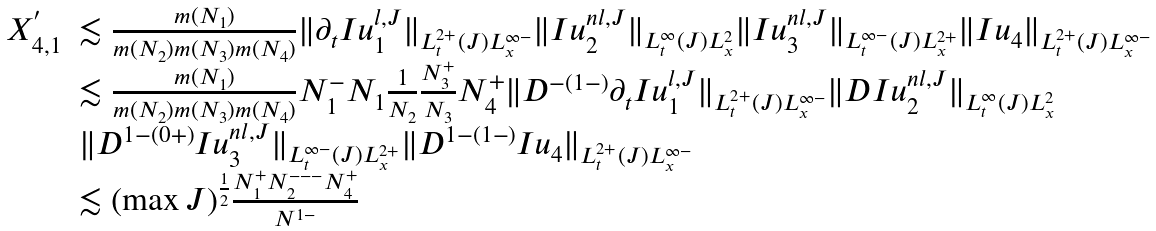Convert formula to latex. <formula><loc_0><loc_0><loc_500><loc_500>\begin{array} { l l } X ^ { ^ { \prime } } _ { 4 , 1 } & \lesssim \frac { m ( N _ { 1 } ) } { m ( N _ { 2 } ) m ( N _ { 3 } ) m ( N _ { 4 } ) } \| \partial _ { t } I u _ { 1 } ^ { l , J } \| _ { L _ { t } ^ { 2 + } ( J ) L _ { x } ^ { \infty - } } \| I u _ { 2 } ^ { n l , J } \| _ { L _ { t } ^ { \infty } ( J ) L _ { x } ^ { 2 } } \| I u _ { 3 } ^ { n l , J } \| _ { L _ { t } ^ { \infty - } ( J ) L _ { x } ^ { 2 + } } \| I u _ { 4 } \| _ { L _ { t } ^ { 2 + } ( J ) L _ { x } ^ { \infty - } } \\ & \lesssim \frac { m ( N _ { 1 } ) } { m ( N _ { 2 } ) m ( N _ { 3 } ) m ( N _ { 4 } ) } N _ { 1 } ^ { - } N _ { 1 } \frac { 1 } { N _ { 2 } } \frac { N _ { 3 } ^ { + } } { N _ { 3 } } N _ { 4 } ^ { + } \| D ^ { - ( 1 - ) } \partial _ { t } I u _ { 1 } ^ { l , J } \| _ { L _ { t } ^ { 2 + } ( J ) L _ { x } ^ { \infty - } } \| D I u _ { 2 } ^ { n l , J } \| _ { L _ { t } ^ { \infty } ( J ) L _ { x } ^ { 2 } } \\ & \| D ^ { 1 - ( 0 + ) } I u _ { 3 } ^ { n l , J } \| _ { L _ { t } ^ { \infty - } ( J ) L _ { x } ^ { 2 + } } \| D ^ { 1 - ( 1 - ) } I u _ { 4 } \| _ { L _ { t } ^ { 2 + } ( J ) L _ { x } ^ { \infty - } } \\ & \lesssim ( \max J ) ^ { \frac { 1 } { 2 } } \frac { N _ { 1 } ^ { + } N _ { 2 } ^ { - - - } N _ { 4 } ^ { + } } { N ^ { 1 - } } \end{array}</formula> 